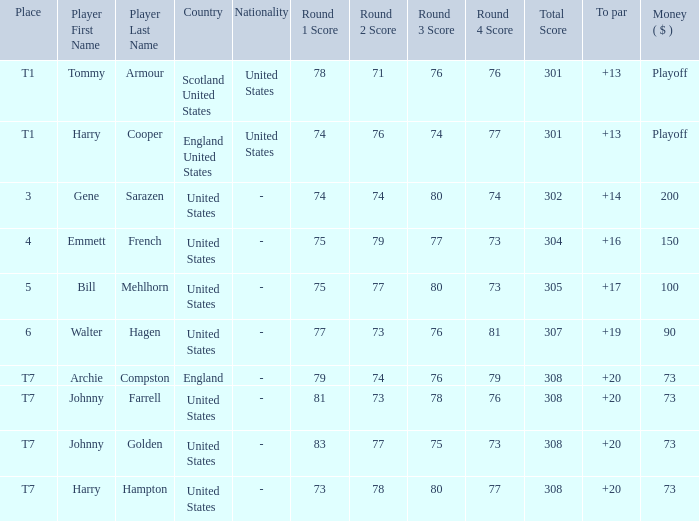Parse the full table. {'header': ['Place', 'Player First Name', 'Player Last Name', 'Country', 'Nationality', 'Round 1 Score', 'Round 2 Score', 'Round 3 Score', 'Round 4 Score', 'Total Score', 'To par', 'Money ( $ )'], 'rows': [['T1', 'Tommy', 'Armour', 'Scotland United States', 'United States', '78', '71', '76', '76', '301', '+13', 'Playoff'], ['T1', 'Harry', 'Cooper', 'England United States', 'United States', '74', '76', '74', '77', '301', '+13', 'Playoff'], ['3', 'Gene', 'Sarazen', 'United States', '-', '74', '74', '80', '74', '302', '+14', '200'], ['4', 'Emmett', 'French', 'United States', '-', '75', '79', '77', '73', '304', '+16', '150'], ['5', 'Bill', 'Mehlhorn', 'United States', '-', '75', '77', '80', '73', '305', '+17', '100'], ['6', 'Walter', 'Hagen', 'United States', '-', '77', '73', '76', '81', '307', '+19', '90'], ['T7', 'Archie', 'Compston', 'England', '-', '79', '74', '76', '79', '308', '+20', '73'], ['T7', 'Johnny', 'Farrell', 'United States', '-', '81', '73', '78', '76', '308', '+20', '73'], ['T7', 'Johnny', 'Golden', 'United States', '-', '83', '77', '75', '73', '308', '+20', '73'], ['T7', 'Harry', 'Hampton', 'United States', '-', '73', '78', '80', '77', '308', '+20', '73']]} What is the united states' tally when harry hampton is the athlete and the cash is $73? 73-78-80-77=308. 